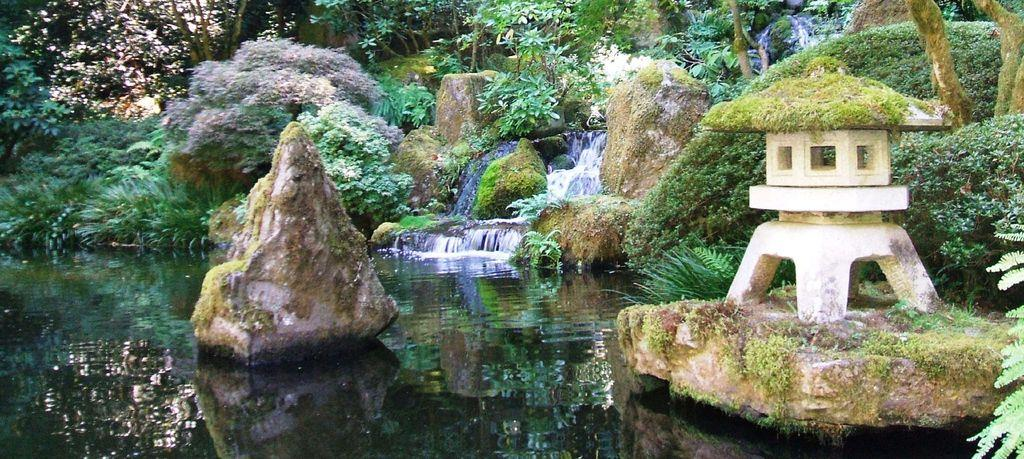What natural feature is the main subject of the image? There is a waterfall in the image. What type of vegetation can be seen in the image? Plants and trees are present in the image. What material is visible in the image? Stones are present in the image. What else is visible in the image besides the waterfall? There is water visible in the image. How does the waterfall stop flowing in the image? The waterfall does not stop flowing in the image; it is continuously flowing. What type of form can be seen stretching across the waterfall in the image? There is no form stretching across the waterfall in the image. 